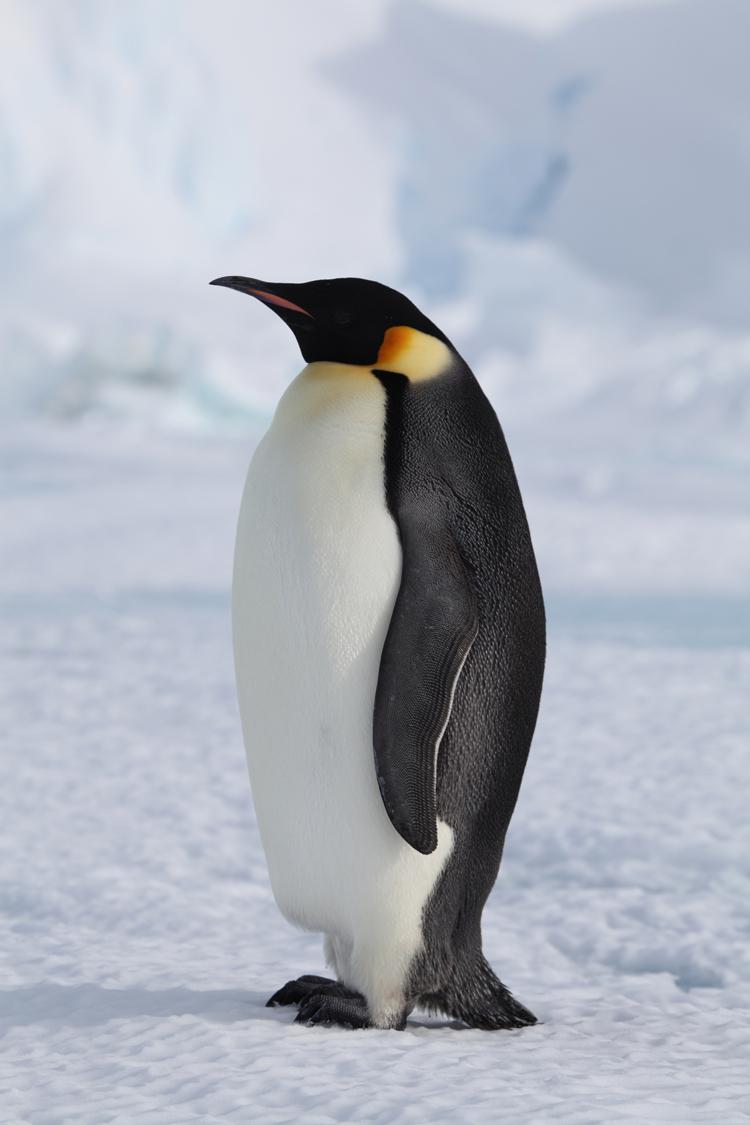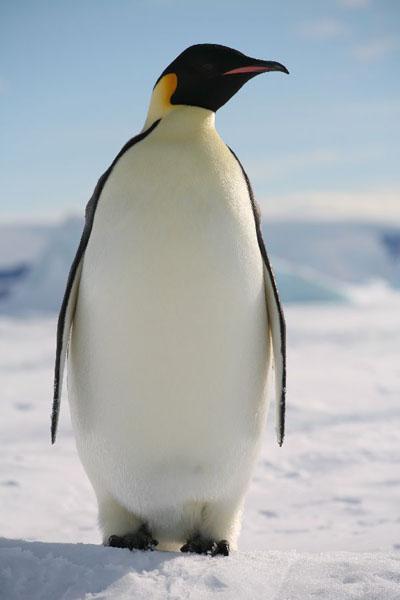The first image is the image on the left, the second image is the image on the right. Examine the images to the left and right. Is the description "Each image shows an upright penguin that is standing in one place rather than walking." accurate? Answer yes or no. Yes. 